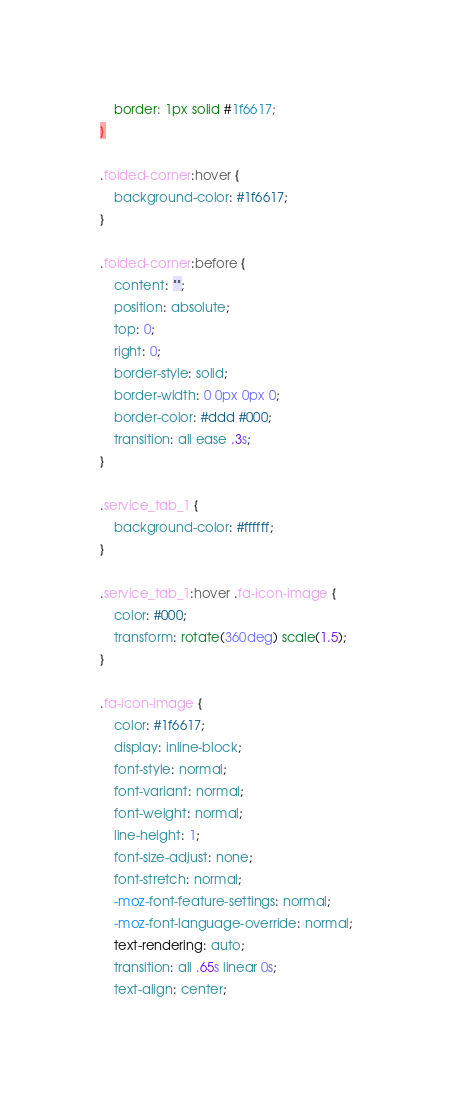Convert code to text. <code><loc_0><loc_0><loc_500><loc_500><_CSS_>    border: 1px solid #1f6617;
}

.folded-corner:hover {
    background-color: #1f6617;
}

.folded-corner:before {
    content: "";
    position: absolute;
    top: 0;
    right: 0;
    border-style: solid;
    border-width: 0 0px 0px 0;
    border-color: #ddd #000;
    transition: all ease .3s;
}

.service_tab_1 {
    background-color: #ffffff;
}

.service_tab_1:hover .fa-icon-image {
    color: #000;
    transform: rotate(360deg) scale(1.5);
}

.fa-icon-image {
    color: #1f6617;
    display: inline-block;
    font-style: normal;
    font-variant: normal;
    font-weight: normal;
    line-height: 1;
    font-size-adjust: none;
    font-stretch: normal;
    -moz-font-feature-settings: normal;
    -moz-font-language-override: normal;
    text-rendering: auto;
    transition: all .65s linear 0s;
    text-align: center;</code> 